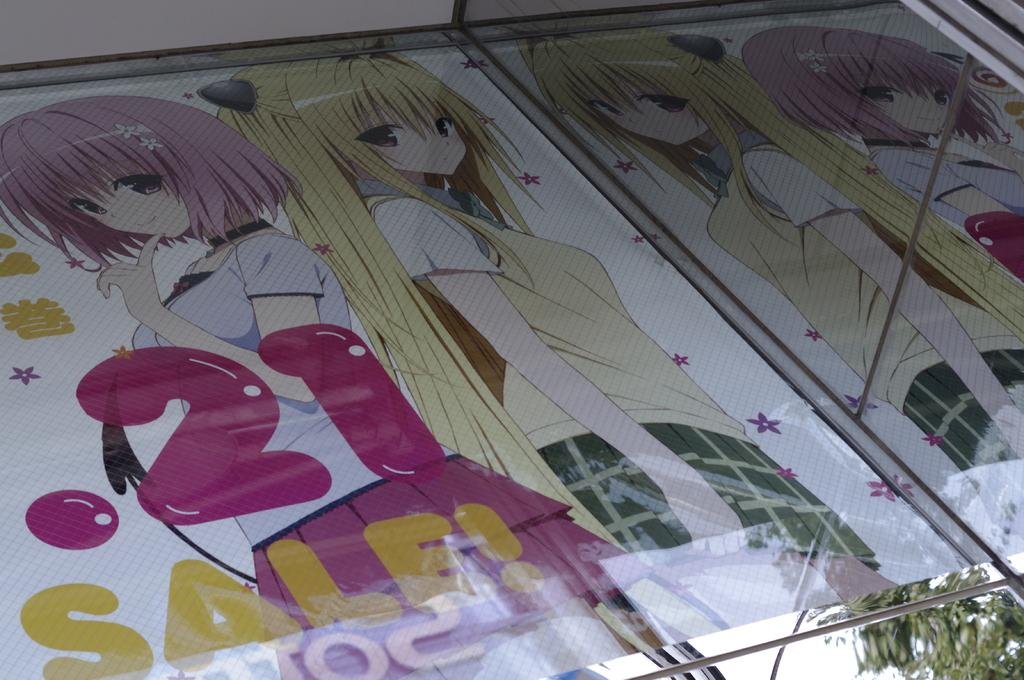What is present in the image that is used for displaying information or advertising? There is a banner in the image. What is depicted on the banner? The banner features two girls. What book is the girl on the left holding in the image? There is no book present in the image; the banner features two girls without any visible objects. 